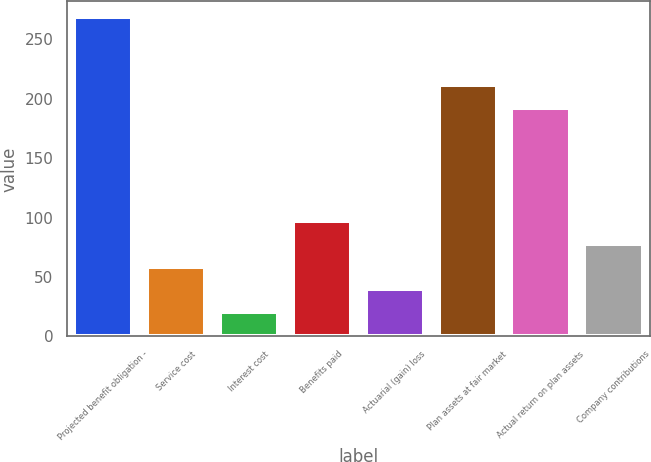Convert chart. <chart><loc_0><loc_0><loc_500><loc_500><bar_chart><fcel>Projected benefit obligation -<fcel>Service cost<fcel>Interest cost<fcel>Benefits paid<fcel>Actuarial (gain) loss<fcel>Plan assets at fair market<fcel>Actual return on plan assets<fcel>Company contributions<nl><fcel>268.42<fcel>58.54<fcel>20.38<fcel>96.7<fcel>39.46<fcel>211.18<fcel>192.1<fcel>77.62<nl></chart> 